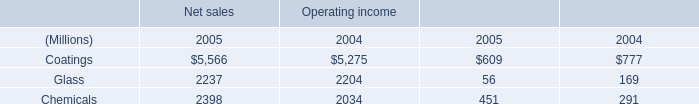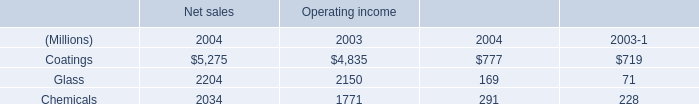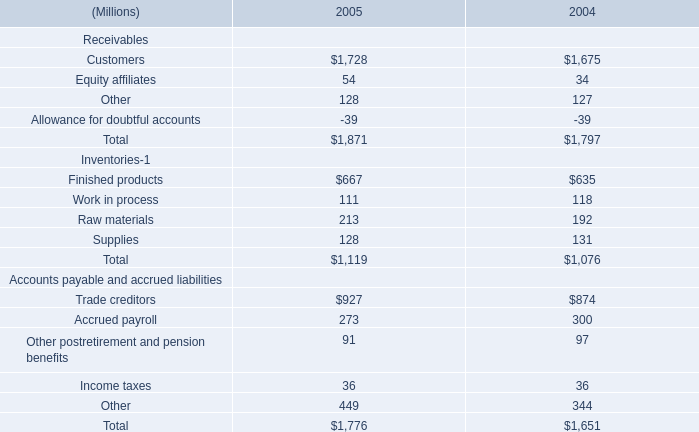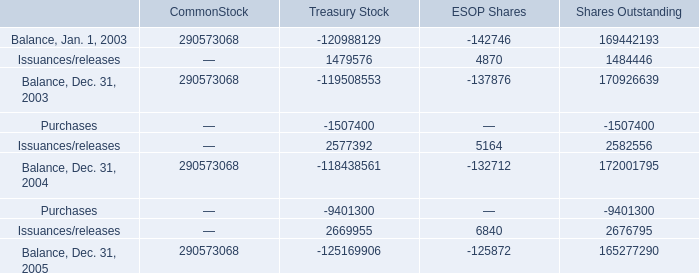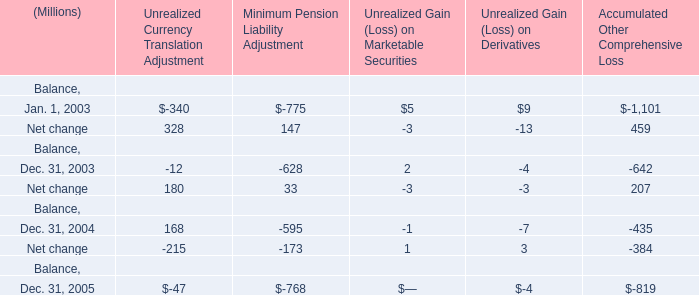What's the total amount of the Minimum Pension Liability Adjustment in the years where Unrealized Gain (Loss) on Marketable Securities is greater than 4? (in million) 
Computations: (-775 + 147)
Answer: -628.0. 